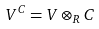Convert formula to latex. <formula><loc_0><loc_0><loc_500><loc_500>V ^ { C } = V \otimes _ { R } C</formula> 